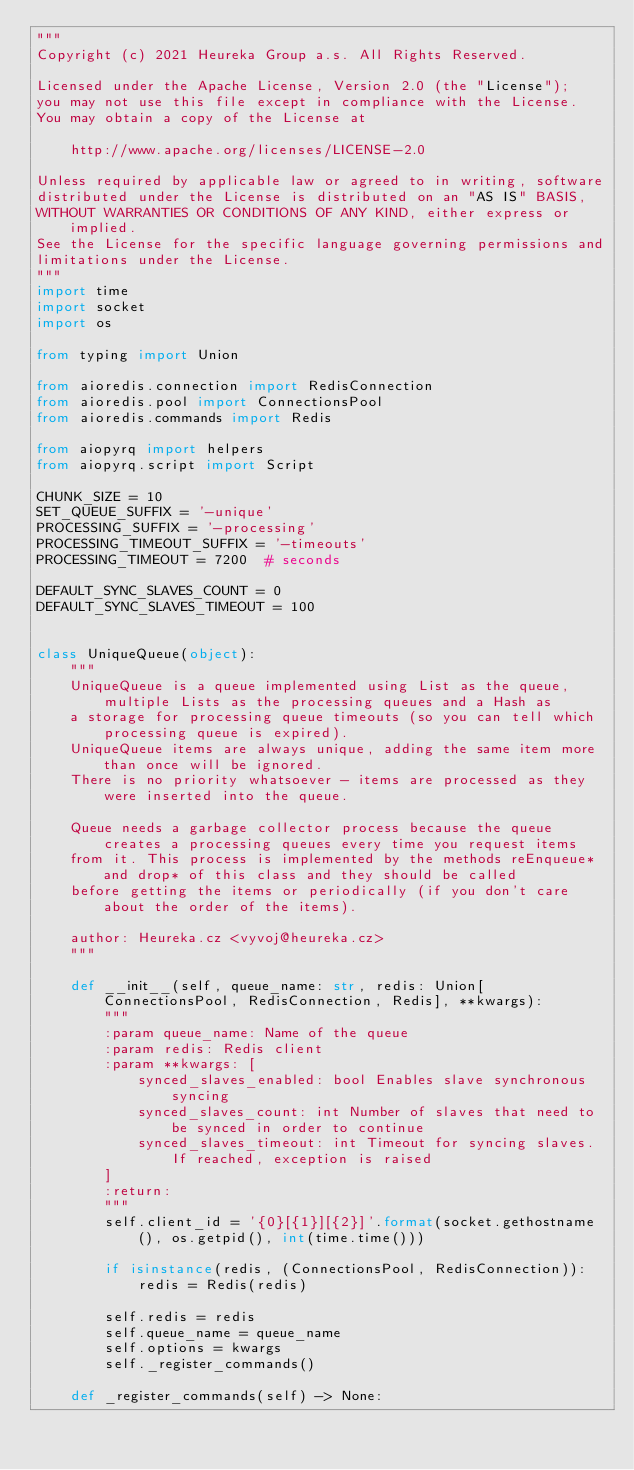Convert code to text. <code><loc_0><loc_0><loc_500><loc_500><_Python_>"""
Copyright (c) 2021 Heureka Group a.s. All Rights Reserved.

Licensed under the Apache License, Version 2.0 (the "License");
you may not use this file except in compliance with the License.
You may obtain a copy of the License at

    http://www.apache.org/licenses/LICENSE-2.0

Unless required by applicable law or agreed to in writing, software
distributed under the License is distributed on an "AS IS" BASIS,
WITHOUT WARRANTIES OR CONDITIONS OF ANY KIND, either express or implied.
See the License for the specific language governing permissions and
limitations under the License.
"""
import time
import socket
import os

from typing import Union

from aioredis.connection import RedisConnection
from aioredis.pool import ConnectionsPool
from aioredis.commands import Redis

from aiopyrq import helpers
from aiopyrq.script import Script

CHUNK_SIZE = 10
SET_QUEUE_SUFFIX = '-unique'
PROCESSING_SUFFIX = '-processing'
PROCESSING_TIMEOUT_SUFFIX = '-timeouts'
PROCESSING_TIMEOUT = 7200  # seconds

DEFAULT_SYNC_SLAVES_COUNT = 0
DEFAULT_SYNC_SLAVES_TIMEOUT = 100


class UniqueQueue(object):
    """
    UniqueQueue is a queue implemented using List as the queue, multiple Lists as the processing queues and a Hash as
    a storage for processing queue timeouts (so you can tell which processing queue is expired).
    UniqueQueue items are always unique, adding the same item more than once will be ignored.
    There is no priority whatsoever - items are processed as they were inserted into the queue.

    Queue needs a garbage collector process because the queue creates a processing queues every time you request items
    from it. This process is implemented by the methods reEnqueue* and drop* of this class and they should be called
    before getting the items or periodically (if you don't care about the order of the items).

    author: Heureka.cz <vyvoj@heureka.cz>
    """

    def __init__(self, queue_name: str, redis: Union[ConnectionsPool, RedisConnection, Redis], **kwargs):
        """
        :param queue_name: Name of the queue
        :param redis: Redis client
        :param **kwargs: [
            synced_slaves_enabled: bool Enables slave synchronous syncing
            synced_slaves_count: int Number of slaves that need to be synced in order to continue
            synced_slaves_timeout: int Timeout for syncing slaves. If reached, exception is raised
        ]
        :return:
        """
        self.client_id = '{0}[{1}][{2}]'.format(socket.gethostname(), os.getpid(), int(time.time()))

        if isinstance(redis, (ConnectionsPool, RedisConnection)):
            redis = Redis(redis)

        self.redis = redis
        self.queue_name = queue_name
        self.options = kwargs
        self._register_commands()

    def _register_commands(self) -> None:</code> 